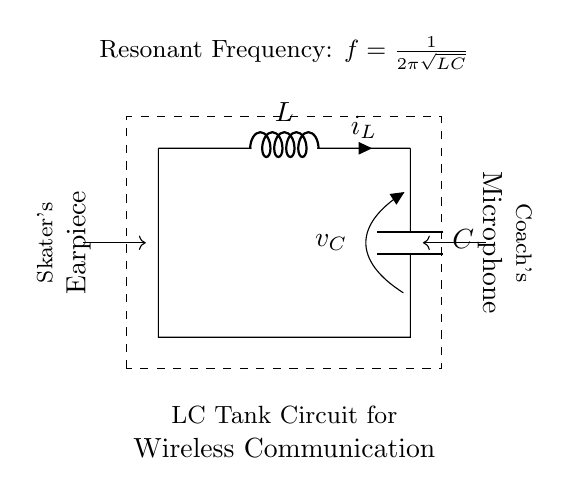What are the components of this circuit? The circuit contains an inductor, a capacitor, and connections indicating them in series as part of an LC tank circuit.
Answer: Inductor and Capacitor What does the dashed rectangle represent? The dashed rectangle designates the area of the LC tank circuit, containing both the inductor and the capacitor as part of a single functional unit.
Answer: LC Tank Circuit What is the current symbol in this circuit? The symbol for current in the circuit is represented by \(i_L\) next to the inductor, indicating the current flowing through it.
Answer: i_L What is the purpose of this circuit? The primary function of the circuit is to facilitate wireless communication, specifically between a coach's microphone and a skater's earpiece during practice sessions.
Answer: Wireless Communication What is the resonant frequency formula for this circuit? The resonant frequency is calculated using the formula provided in the circuit, which is \(f = \frac{1}{2\pi\sqrt{LC}}\), where \(L\) is the inductance and \(C\) is the capacitance.
Answer: f = 1 / (2π√(LC)) How does this circuit contribute to wireless communication? The LC tank circuit enables the generation of oscillations at a specific frequency, which allows for effective transmission of signals wirelessly between the coach and skater.
Answer: Generates oscillations What happens if the values of the inductor and capacitor are equal? If the values of the inductor and capacitor are equal, the circuit will reach resonance at a specific frequency, maximizing the energy transfer and allowing for efficient signal transmission.
Answer: Resonance occurs 